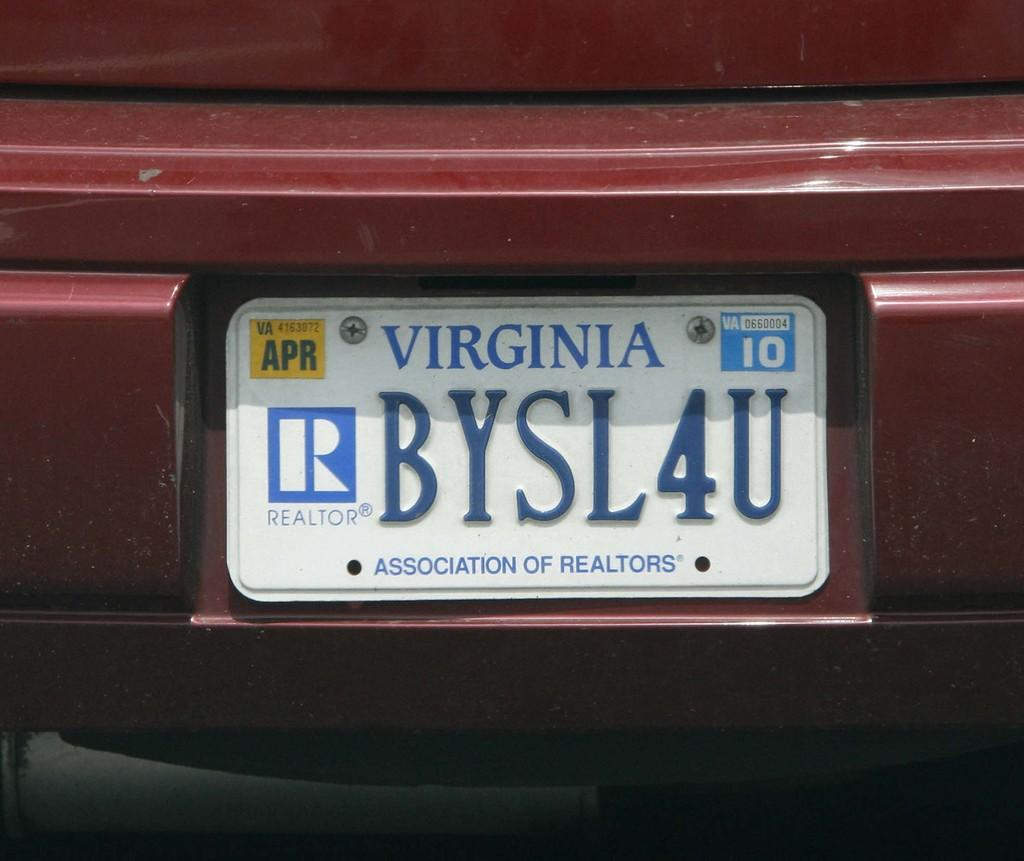<image>
Summarize the visual content of the image. A red car has a Virginia license plate with the text BYSL4U. 